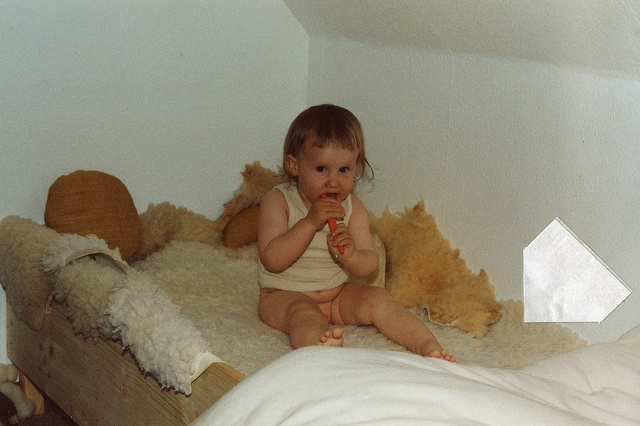Describe the objects in this image and their specific colors. I can see bed in darkgray, maroon, and gray tones, people in darkgray, maroon, brown, and gray tones, and toothbrush in darkgray, brown, and maroon tones in this image. 